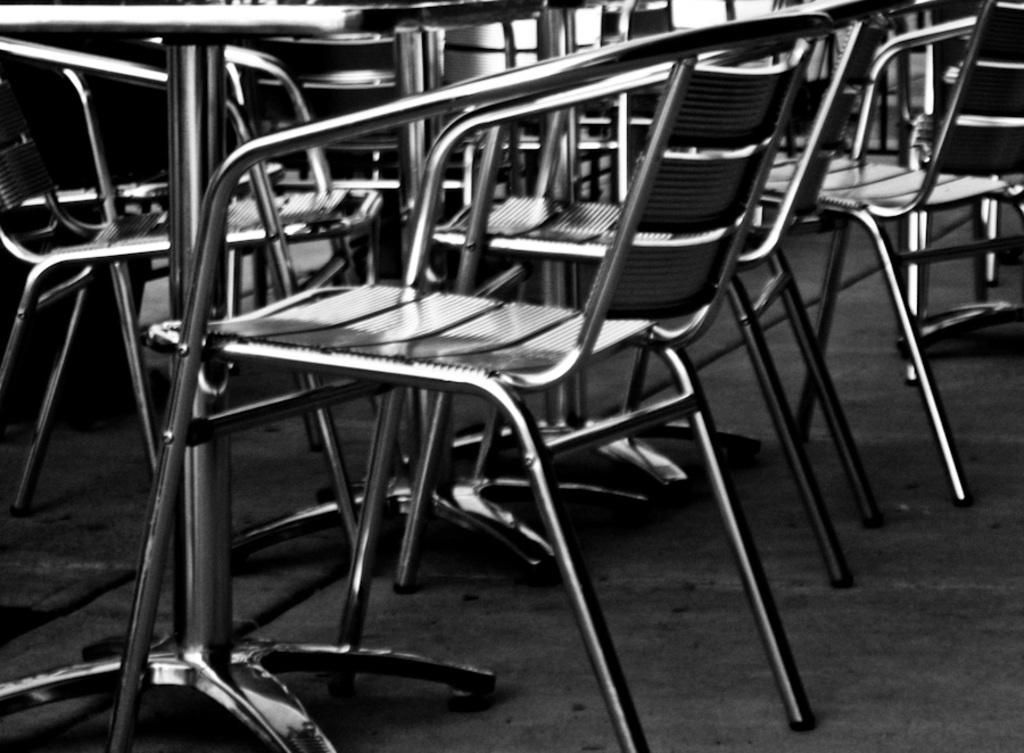What type of furniture is present in the image? There are many chairs and a table in the image. What can be seen beneath the chairs and table? The floor is visible in the image. How many sheets of paper are on the table in the image? There is no paper visible on the table in the image. Is there a kettle on the floor in the image? There is no kettle present in the image. 